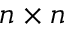<formula> <loc_0><loc_0><loc_500><loc_500>n \times n</formula> 